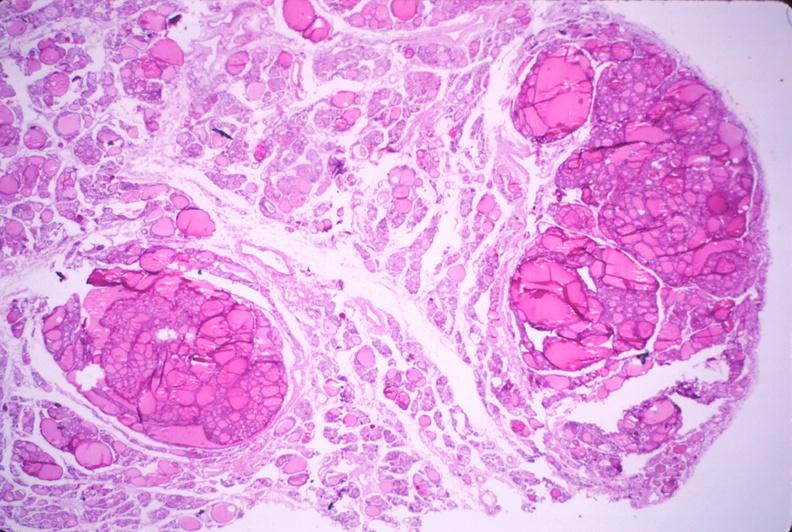does this image show thyroid, nodular hyperplasia?
Answer the question using a single word or phrase. Yes 